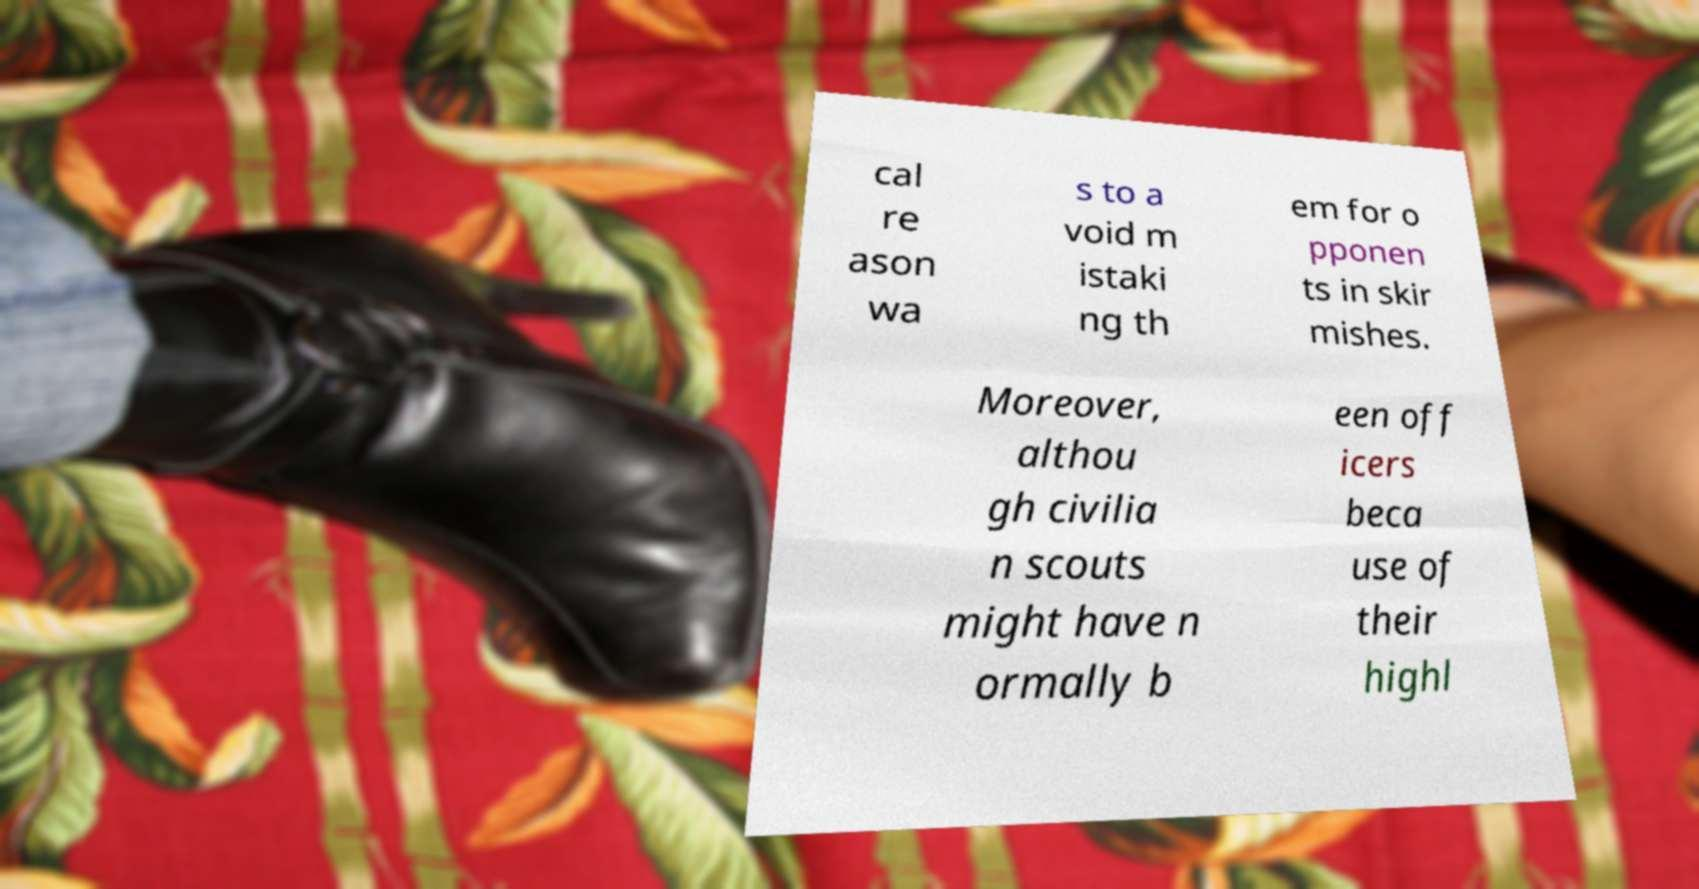Can you read and provide the text displayed in the image?This photo seems to have some interesting text. Can you extract and type it out for me? cal re ason wa s to a void m istaki ng th em for o pponen ts in skir mishes. Moreover, althou gh civilia n scouts might have n ormally b een off icers beca use of their highl 